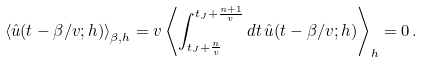Convert formula to latex. <formula><loc_0><loc_0><loc_500><loc_500>\left \langle \hat { u } ( t - \beta / v ; h ) \right \rangle _ { \beta , h } = v \left \langle \int _ { t _ { J } + \frac { n } { v } } ^ { t _ { J } + \frac { n + 1 } { v } } d t \, \hat { u } ( t - \beta / v ; h ) \right \rangle _ { h } = 0 \, .</formula> 